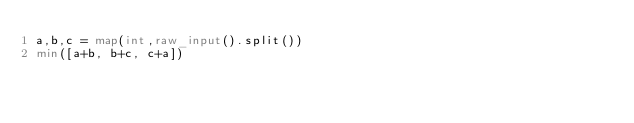<code> <loc_0><loc_0><loc_500><loc_500><_Python_>a,b,c = map(int,raw_input().split())
min([a+b, b+c, c+a])</code> 